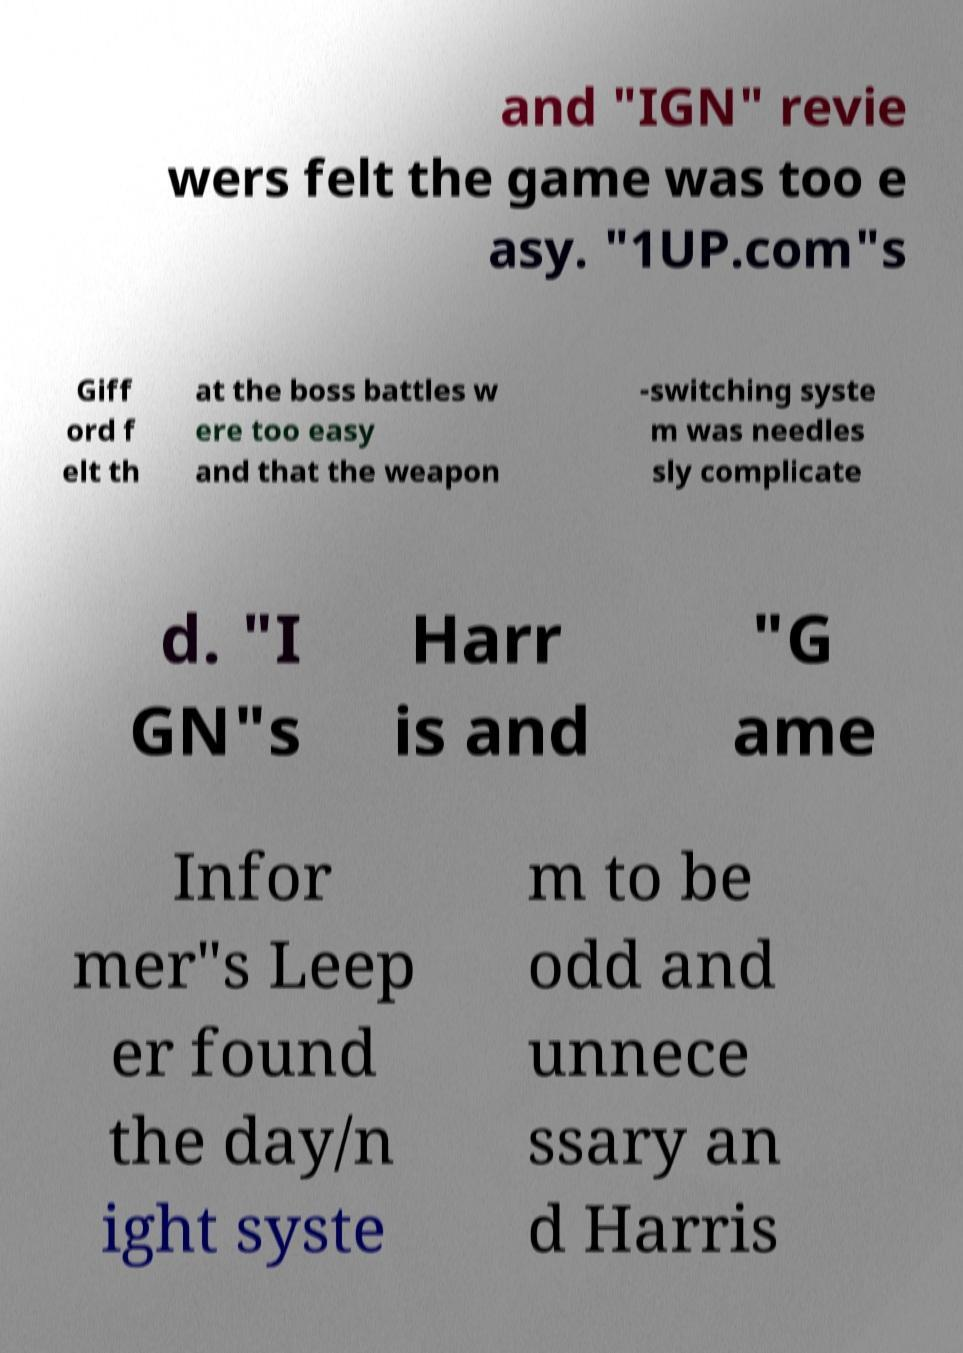Please identify and transcribe the text found in this image. and "IGN" revie wers felt the game was too e asy. "1UP.com"s Giff ord f elt th at the boss battles w ere too easy and that the weapon -switching syste m was needles sly complicate d. "I GN"s Harr is and "G ame Infor mer"s Leep er found the day/n ight syste m to be odd and unnece ssary an d Harris 